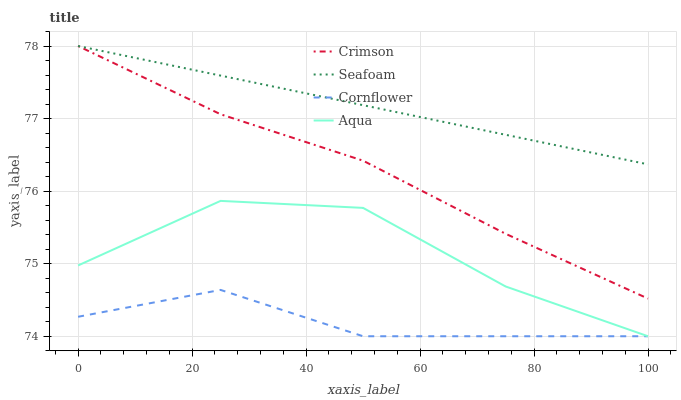Does Cornflower have the minimum area under the curve?
Answer yes or no. Yes. Does Seafoam have the maximum area under the curve?
Answer yes or no. Yes. Does Aqua have the minimum area under the curve?
Answer yes or no. No. Does Aqua have the maximum area under the curve?
Answer yes or no. No. Is Seafoam the smoothest?
Answer yes or no. Yes. Is Aqua the roughest?
Answer yes or no. Yes. Is Cornflower the smoothest?
Answer yes or no. No. Is Cornflower the roughest?
Answer yes or no. No. Does Cornflower have the lowest value?
Answer yes or no. Yes. Does Seafoam have the lowest value?
Answer yes or no. No. Does Seafoam have the highest value?
Answer yes or no. Yes. Does Aqua have the highest value?
Answer yes or no. No. Is Aqua less than Seafoam?
Answer yes or no. Yes. Is Crimson greater than Aqua?
Answer yes or no. Yes. Does Aqua intersect Cornflower?
Answer yes or no. Yes. Is Aqua less than Cornflower?
Answer yes or no. No. Is Aqua greater than Cornflower?
Answer yes or no. No. Does Aqua intersect Seafoam?
Answer yes or no. No. 